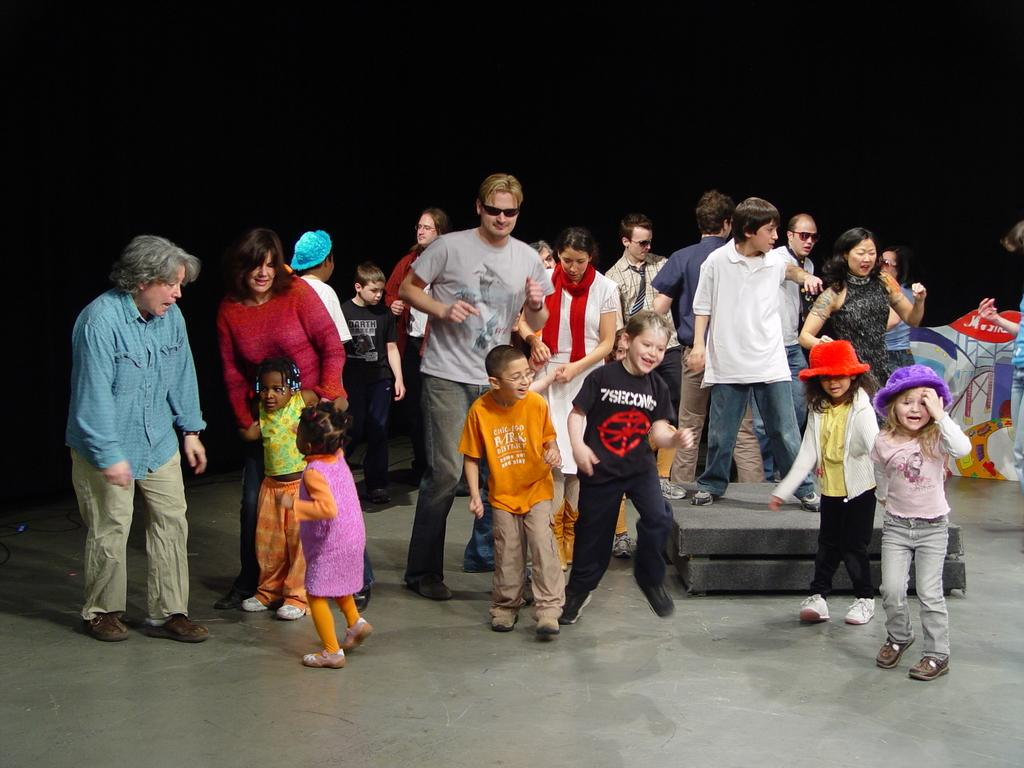What is happening in the image involving people? There are people standing in the image. What can be seen on the surface in the image? There are objects on the surface in the image. What activity are the children engaged in? There are children dancing in the image. What type of bat is hanging from the ceiling in the image? There is no bat hanging from the ceiling in the image. Is there a light bulb visible in the image? The provided facts do not mention a light bulb, so we cannot determine if one is visible in the image. What is the cause of death in the image? There is no mention of death or any related event in the image. 